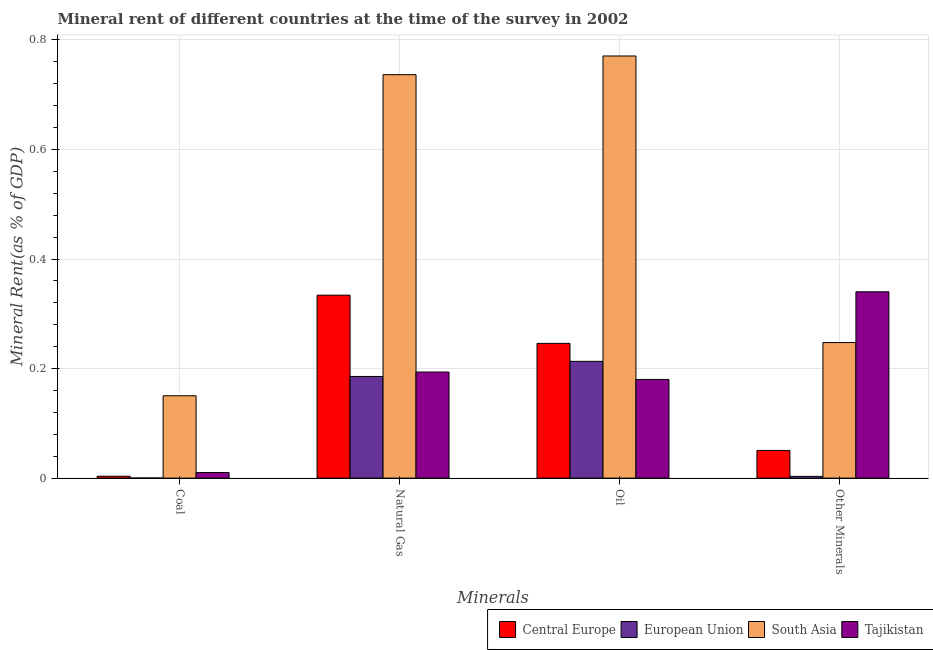How many different coloured bars are there?
Your answer should be compact. 4. How many bars are there on the 4th tick from the right?
Make the answer very short. 4. What is the label of the 4th group of bars from the left?
Keep it short and to the point. Other Minerals. What is the oil rent in South Asia?
Keep it short and to the point. 0.77. Across all countries, what is the maximum natural gas rent?
Your answer should be compact. 0.74. Across all countries, what is the minimum  rent of other minerals?
Offer a very short reply. 0. In which country was the  rent of other minerals maximum?
Give a very brief answer. Tajikistan. In which country was the coal rent minimum?
Your answer should be compact. European Union. What is the total  rent of other minerals in the graph?
Ensure brevity in your answer.  0.64. What is the difference between the  rent of other minerals in Central Europe and that in European Union?
Offer a terse response. 0.05. What is the difference between the natural gas rent in European Union and the oil rent in South Asia?
Keep it short and to the point. -0.59. What is the average natural gas rent per country?
Your response must be concise. 0.36. What is the difference between the oil rent and natural gas rent in Central Europe?
Make the answer very short. -0.09. What is the ratio of the  rent of other minerals in South Asia to that in Central Europe?
Provide a succinct answer. 4.9. What is the difference between the highest and the second highest coal rent?
Your response must be concise. 0.14. What is the difference between the highest and the lowest natural gas rent?
Offer a very short reply. 0.55. In how many countries, is the coal rent greater than the average coal rent taken over all countries?
Offer a terse response. 1. Is it the case that in every country, the sum of the oil rent and coal rent is greater than the sum of natural gas rent and  rent of other minerals?
Provide a short and direct response. No. What does the 4th bar from the left in Coal represents?
Offer a very short reply. Tajikistan. What does the 1st bar from the right in Natural Gas represents?
Keep it short and to the point. Tajikistan. How many bars are there?
Your answer should be very brief. 16. Are the values on the major ticks of Y-axis written in scientific E-notation?
Keep it short and to the point. No. Does the graph contain any zero values?
Offer a very short reply. No. How many legend labels are there?
Offer a terse response. 4. What is the title of the graph?
Your answer should be very brief. Mineral rent of different countries at the time of the survey in 2002. What is the label or title of the X-axis?
Make the answer very short. Minerals. What is the label or title of the Y-axis?
Provide a short and direct response. Mineral Rent(as % of GDP). What is the Mineral Rent(as % of GDP) of Central Europe in Coal?
Provide a short and direct response. 0. What is the Mineral Rent(as % of GDP) of European Union in Coal?
Give a very brief answer. 0. What is the Mineral Rent(as % of GDP) in South Asia in Coal?
Offer a very short reply. 0.15. What is the Mineral Rent(as % of GDP) of Tajikistan in Coal?
Make the answer very short. 0.01. What is the Mineral Rent(as % of GDP) of Central Europe in Natural Gas?
Offer a very short reply. 0.33. What is the Mineral Rent(as % of GDP) of European Union in Natural Gas?
Your answer should be compact. 0.19. What is the Mineral Rent(as % of GDP) of South Asia in Natural Gas?
Provide a succinct answer. 0.74. What is the Mineral Rent(as % of GDP) in Tajikistan in Natural Gas?
Provide a succinct answer. 0.19. What is the Mineral Rent(as % of GDP) in Central Europe in Oil?
Provide a short and direct response. 0.25. What is the Mineral Rent(as % of GDP) in European Union in Oil?
Your response must be concise. 0.21. What is the Mineral Rent(as % of GDP) of South Asia in Oil?
Your answer should be very brief. 0.77. What is the Mineral Rent(as % of GDP) of Tajikistan in Oil?
Your answer should be compact. 0.18. What is the Mineral Rent(as % of GDP) in Central Europe in Other Minerals?
Keep it short and to the point. 0.05. What is the Mineral Rent(as % of GDP) of European Union in Other Minerals?
Your answer should be very brief. 0. What is the Mineral Rent(as % of GDP) of South Asia in Other Minerals?
Ensure brevity in your answer.  0.25. What is the Mineral Rent(as % of GDP) in Tajikistan in Other Minerals?
Provide a short and direct response. 0.34. Across all Minerals, what is the maximum Mineral Rent(as % of GDP) of Central Europe?
Offer a very short reply. 0.33. Across all Minerals, what is the maximum Mineral Rent(as % of GDP) of European Union?
Make the answer very short. 0.21. Across all Minerals, what is the maximum Mineral Rent(as % of GDP) of South Asia?
Keep it short and to the point. 0.77. Across all Minerals, what is the maximum Mineral Rent(as % of GDP) in Tajikistan?
Your answer should be compact. 0.34. Across all Minerals, what is the minimum Mineral Rent(as % of GDP) in Central Europe?
Ensure brevity in your answer.  0. Across all Minerals, what is the minimum Mineral Rent(as % of GDP) in European Union?
Your answer should be very brief. 0. Across all Minerals, what is the minimum Mineral Rent(as % of GDP) of South Asia?
Keep it short and to the point. 0.15. Across all Minerals, what is the minimum Mineral Rent(as % of GDP) of Tajikistan?
Make the answer very short. 0.01. What is the total Mineral Rent(as % of GDP) of Central Europe in the graph?
Your answer should be very brief. 0.63. What is the total Mineral Rent(as % of GDP) in European Union in the graph?
Your answer should be very brief. 0.4. What is the total Mineral Rent(as % of GDP) of South Asia in the graph?
Offer a very short reply. 1.91. What is the total Mineral Rent(as % of GDP) in Tajikistan in the graph?
Provide a short and direct response. 0.72. What is the difference between the Mineral Rent(as % of GDP) in Central Europe in Coal and that in Natural Gas?
Keep it short and to the point. -0.33. What is the difference between the Mineral Rent(as % of GDP) of European Union in Coal and that in Natural Gas?
Keep it short and to the point. -0.19. What is the difference between the Mineral Rent(as % of GDP) in South Asia in Coal and that in Natural Gas?
Your answer should be very brief. -0.59. What is the difference between the Mineral Rent(as % of GDP) in Tajikistan in Coal and that in Natural Gas?
Provide a short and direct response. -0.18. What is the difference between the Mineral Rent(as % of GDP) of Central Europe in Coal and that in Oil?
Make the answer very short. -0.24. What is the difference between the Mineral Rent(as % of GDP) in European Union in Coal and that in Oil?
Your answer should be compact. -0.21. What is the difference between the Mineral Rent(as % of GDP) of South Asia in Coal and that in Oil?
Provide a short and direct response. -0.62. What is the difference between the Mineral Rent(as % of GDP) of Tajikistan in Coal and that in Oil?
Your response must be concise. -0.17. What is the difference between the Mineral Rent(as % of GDP) of Central Europe in Coal and that in Other Minerals?
Make the answer very short. -0.05. What is the difference between the Mineral Rent(as % of GDP) in European Union in Coal and that in Other Minerals?
Make the answer very short. -0. What is the difference between the Mineral Rent(as % of GDP) of South Asia in Coal and that in Other Minerals?
Your answer should be compact. -0.1. What is the difference between the Mineral Rent(as % of GDP) of Tajikistan in Coal and that in Other Minerals?
Your answer should be very brief. -0.33. What is the difference between the Mineral Rent(as % of GDP) of Central Europe in Natural Gas and that in Oil?
Provide a succinct answer. 0.09. What is the difference between the Mineral Rent(as % of GDP) in European Union in Natural Gas and that in Oil?
Your answer should be very brief. -0.03. What is the difference between the Mineral Rent(as % of GDP) of South Asia in Natural Gas and that in Oil?
Make the answer very short. -0.03. What is the difference between the Mineral Rent(as % of GDP) in Tajikistan in Natural Gas and that in Oil?
Keep it short and to the point. 0.01. What is the difference between the Mineral Rent(as % of GDP) of Central Europe in Natural Gas and that in Other Minerals?
Give a very brief answer. 0.28. What is the difference between the Mineral Rent(as % of GDP) of European Union in Natural Gas and that in Other Minerals?
Offer a very short reply. 0.18. What is the difference between the Mineral Rent(as % of GDP) of South Asia in Natural Gas and that in Other Minerals?
Keep it short and to the point. 0.49. What is the difference between the Mineral Rent(as % of GDP) in Tajikistan in Natural Gas and that in Other Minerals?
Offer a terse response. -0.15. What is the difference between the Mineral Rent(as % of GDP) in Central Europe in Oil and that in Other Minerals?
Your response must be concise. 0.2. What is the difference between the Mineral Rent(as % of GDP) of European Union in Oil and that in Other Minerals?
Make the answer very short. 0.21. What is the difference between the Mineral Rent(as % of GDP) in South Asia in Oil and that in Other Minerals?
Your answer should be very brief. 0.52. What is the difference between the Mineral Rent(as % of GDP) in Tajikistan in Oil and that in Other Minerals?
Provide a succinct answer. -0.16. What is the difference between the Mineral Rent(as % of GDP) in Central Europe in Coal and the Mineral Rent(as % of GDP) in European Union in Natural Gas?
Provide a succinct answer. -0.18. What is the difference between the Mineral Rent(as % of GDP) of Central Europe in Coal and the Mineral Rent(as % of GDP) of South Asia in Natural Gas?
Your answer should be very brief. -0.73. What is the difference between the Mineral Rent(as % of GDP) of Central Europe in Coal and the Mineral Rent(as % of GDP) of Tajikistan in Natural Gas?
Your response must be concise. -0.19. What is the difference between the Mineral Rent(as % of GDP) in European Union in Coal and the Mineral Rent(as % of GDP) in South Asia in Natural Gas?
Ensure brevity in your answer.  -0.74. What is the difference between the Mineral Rent(as % of GDP) in European Union in Coal and the Mineral Rent(as % of GDP) in Tajikistan in Natural Gas?
Offer a terse response. -0.19. What is the difference between the Mineral Rent(as % of GDP) in South Asia in Coal and the Mineral Rent(as % of GDP) in Tajikistan in Natural Gas?
Make the answer very short. -0.04. What is the difference between the Mineral Rent(as % of GDP) in Central Europe in Coal and the Mineral Rent(as % of GDP) in European Union in Oil?
Offer a very short reply. -0.21. What is the difference between the Mineral Rent(as % of GDP) in Central Europe in Coal and the Mineral Rent(as % of GDP) in South Asia in Oil?
Keep it short and to the point. -0.77. What is the difference between the Mineral Rent(as % of GDP) in Central Europe in Coal and the Mineral Rent(as % of GDP) in Tajikistan in Oil?
Your answer should be very brief. -0.18. What is the difference between the Mineral Rent(as % of GDP) of European Union in Coal and the Mineral Rent(as % of GDP) of South Asia in Oil?
Provide a short and direct response. -0.77. What is the difference between the Mineral Rent(as % of GDP) of European Union in Coal and the Mineral Rent(as % of GDP) of Tajikistan in Oil?
Offer a very short reply. -0.18. What is the difference between the Mineral Rent(as % of GDP) of South Asia in Coal and the Mineral Rent(as % of GDP) of Tajikistan in Oil?
Provide a short and direct response. -0.03. What is the difference between the Mineral Rent(as % of GDP) of Central Europe in Coal and the Mineral Rent(as % of GDP) of South Asia in Other Minerals?
Ensure brevity in your answer.  -0.24. What is the difference between the Mineral Rent(as % of GDP) in Central Europe in Coal and the Mineral Rent(as % of GDP) in Tajikistan in Other Minerals?
Give a very brief answer. -0.34. What is the difference between the Mineral Rent(as % of GDP) in European Union in Coal and the Mineral Rent(as % of GDP) in South Asia in Other Minerals?
Keep it short and to the point. -0.25. What is the difference between the Mineral Rent(as % of GDP) of European Union in Coal and the Mineral Rent(as % of GDP) of Tajikistan in Other Minerals?
Keep it short and to the point. -0.34. What is the difference between the Mineral Rent(as % of GDP) in South Asia in Coal and the Mineral Rent(as % of GDP) in Tajikistan in Other Minerals?
Make the answer very short. -0.19. What is the difference between the Mineral Rent(as % of GDP) in Central Europe in Natural Gas and the Mineral Rent(as % of GDP) in European Union in Oil?
Provide a short and direct response. 0.12. What is the difference between the Mineral Rent(as % of GDP) of Central Europe in Natural Gas and the Mineral Rent(as % of GDP) of South Asia in Oil?
Provide a succinct answer. -0.44. What is the difference between the Mineral Rent(as % of GDP) in Central Europe in Natural Gas and the Mineral Rent(as % of GDP) in Tajikistan in Oil?
Make the answer very short. 0.15. What is the difference between the Mineral Rent(as % of GDP) in European Union in Natural Gas and the Mineral Rent(as % of GDP) in South Asia in Oil?
Make the answer very short. -0.59. What is the difference between the Mineral Rent(as % of GDP) in European Union in Natural Gas and the Mineral Rent(as % of GDP) in Tajikistan in Oil?
Keep it short and to the point. 0.01. What is the difference between the Mineral Rent(as % of GDP) in South Asia in Natural Gas and the Mineral Rent(as % of GDP) in Tajikistan in Oil?
Your response must be concise. 0.56. What is the difference between the Mineral Rent(as % of GDP) in Central Europe in Natural Gas and the Mineral Rent(as % of GDP) in European Union in Other Minerals?
Make the answer very short. 0.33. What is the difference between the Mineral Rent(as % of GDP) in Central Europe in Natural Gas and the Mineral Rent(as % of GDP) in South Asia in Other Minerals?
Your answer should be very brief. 0.09. What is the difference between the Mineral Rent(as % of GDP) in Central Europe in Natural Gas and the Mineral Rent(as % of GDP) in Tajikistan in Other Minerals?
Offer a terse response. -0.01. What is the difference between the Mineral Rent(as % of GDP) of European Union in Natural Gas and the Mineral Rent(as % of GDP) of South Asia in Other Minerals?
Keep it short and to the point. -0.06. What is the difference between the Mineral Rent(as % of GDP) of European Union in Natural Gas and the Mineral Rent(as % of GDP) of Tajikistan in Other Minerals?
Provide a succinct answer. -0.15. What is the difference between the Mineral Rent(as % of GDP) in South Asia in Natural Gas and the Mineral Rent(as % of GDP) in Tajikistan in Other Minerals?
Your answer should be very brief. 0.4. What is the difference between the Mineral Rent(as % of GDP) of Central Europe in Oil and the Mineral Rent(as % of GDP) of European Union in Other Minerals?
Your answer should be very brief. 0.24. What is the difference between the Mineral Rent(as % of GDP) in Central Europe in Oil and the Mineral Rent(as % of GDP) in South Asia in Other Minerals?
Provide a short and direct response. -0. What is the difference between the Mineral Rent(as % of GDP) in Central Europe in Oil and the Mineral Rent(as % of GDP) in Tajikistan in Other Minerals?
Provide a short and direct response. -0.09. What is the difference between the Mineral Rent(as % of GDP) of European Union in Oil and the Mineral Rent(as % of GDP) of South Asia in Other Minerals?
Your response must be concise. -0.03. What is the difference between the Mineral Rent(as % of GDP) of European Union in Oil and the Mineral Rent(as % of GDP) of Tajikistan in Other Minerals?
Keep it short and to the point. -0.13. What is the difference between the Mineral Rent(as % of GDP) of South Asia in Oil and the Mineral Rent(as % of GDP) of Tajikistan in Other Minerals?
Your answer should be very brief. 0.43. What is the average Mineral Rent(as % of GDP) in Central Europe per Minerals?
Give a very brief answer. 0.16. What is the average Mineral Rent(as % of GDP) of European Union per Minerals?
Provide a short and direct response. 0.1. What is the average Mineral Rent(as % of GDP) of South Asia per Minerals?
Your answer should be very brief. 0.48. What is the average Mineral Rent(as % of GDP) of Tajikistan per Minerals?
Your answer should be very brief. 0.18. What is the difference between the Mineral Rent(as % of GDP) in Central Europe and Mineral Rent(as % of GDP) in European Union in Coal?
Keep it short and to the point. 0. What is the difference between the Mineral Rent(as % of GDP) in Central Europe and Mineral Rent(as % of GDP) in South Asia in Coal?
Your response must be concise. -0.15. What is the difference between the Mineral Rent(as % of GDP) of Central Europe and Mineral Rent(as % of GDP) of Tajikistan in Coal?
Make the answer very short. -0.01. What is the difference between the Mineral Rent(as % of GDP) of European Union and Mineral Rent(as % of GDP) of South Asia in Coal?
Provide a short and direct response. -0.15. What is the difference between the Mineral Rent(as % of GDP) in European Union and Mineral Rent(as % of GDP) in Tajikistan in Coal?
Your response must be concise. -0.01. What is the difference between the Mineral Rent(as % of GDP) of South Asia and Mineral Rent(as % of GDP) of Tajikistan in Coal?
Offer a terse response. 0.14. What is the difference between the Mineral Rent(as % of GDP) in Central Europe and Mineral Rent(as % of GDP) in European Union in Natural Gas?
Ensure brevity in your answer.  0.15. What is the difference between the Mineral Rent(as % of GDP) in Central Europe and Mineral Rent(as % of GDP) in South Asia in Natural Gas?
Ensure brevity in your answer.  -0.4. What is the difference between the Mineral Rent(as % of GDP) of Central Europe and Mineral Rent(as % of GDP) of Tajikistan in Natural Gas?
Your answer should be compact. 0.14. What is the difference between the Mineral Rent(as % of GDP) of European Union and Mineral Rent(as % of GDP) of South Asia in Natural Gas?
Give a very brief answer. -0.55. What is the difference between the Mineral Rent(as % of GDP) in European Union and Mineral Rent(as % of GDP) in Tajikistan in Natural Gas?
Provide a succinct answer. -0.01. What is the difference between the Mineral Rent(as % of GDP) in South Asia and Mineral Rent(as % of GDP) in Tajikistan in Natural Gas?
Your answer should be very brief. 0.54. What is the difference between the Mineral Rent(as % of GDP) in Central Europe and Mineral Rent(as % of GDP) in European Union in Oil?
Offer a very short reply. 0.03. What is the difference between the Mineral Rent(as % of GDP) in Central Europe and Mineral Rent(as % of GDP) in South Asia in Oil?
Your answer should be very brief. -0.52. What is the difference between the Mineral Rent(as % of GDP) in Central Europe and Mineral Rent(as % of GDP) in Tajikistan in Oil?
Ensure brevity in your answer.  0.07. What is the difference between the Mineral Rent(as % of GDP) in European Union and Mineral Rent(as % of GDP) in South Asia in Oil?
Your answer should be very brief. -0.56. What is the difference between the Mineral Rent(as % of GDP) in European Union and Mineral Rent(as % of GDP) in Tajikistan in Oil?
Your answer should be very brief. 0.03. What is the difference between the Mineral Rent(as % of GDP) in South Asia and Mineral Rent(as % of GDP) in Tajikistan in Oil?
Your answer should be very brief. 0.59. What is the difference between the Mineral Rent(as % of GDP) of Central Europe and Mineral Rent(as % of GDP) of European Union in Other Minerals?
Provide a succinct answer. 0.05. What is the difference between the Mineral Rent(as % of GDP) in Central Europe and Mineral Rent(as % of GDP) in South Asia in Other Minerals?
Provide a succinct answer. -0.2. What is the difference between the Mineral Rent(as % of GDP) of Central Europe and Mineral Rent(as % of GDP) of Tajikistan in Other Minerals?
Keep it short and to the point. -0.29. What is the difference between the Mineral Rent(as % of GDP) of European Union and Mineral Rent(as % of GDP) of South Asia in Other Minerals?
Your answer should be compact. -0.24. What is the difference between the Mineral Rent(as % of GDP) of European Union and Mineral Rent(as % of GDP) of Tajikistan in Other Minerals?
Provide a short and direct response. -0.34. What is the difference between the Mineral Rent(as % of GDP) of South Asia and Mineral Rent(as % of GDP) of Tajikistan in Other Minerals?
Your answer should be very brief. -0.09. What is the ratio of the Mineral Rent(as % of GDP) in Central Europe in Coal to that in Natural Gas?
Give a very brief answer. 0.01. What is the ratio of the Mineral Rent(as % of GDP) of European Union in Coal to that in Natural Gas?
Offer a terse response. 0. What is the ratio of the Mineral Rent(as % of GDP) of South Asia in Coal to that in Natural Gas?
Offer a very short reply. 0.2. What is the ratio of the Mineral Rent(as % of GDP) of Tajikistan in Coal to that in Natural Gas?
Offer a very short reply. 0.05. What is the ratio of the Mineral Rent(as % of GDP) of Central Europe in Coal to that in Oil?
Offer a very short reply. 0.01. What is the ratio of the Mineral Rent(as % of GDP) of European Union in Coal to that in Oil?
Provide a short and direct response. 0. What is the ratio of the Mineral Rent(as % of GDP) of South Asia in Coal to that in Oil?
Keep it short and to the point. 0.2. What is the ratio of the Mineral Rent(as % of GDP) in Tajikistan in Coal to that in Oil?
Keep it short and to the point. 0.06. What is the ratio of the Mineral Rent(as % of GDP) in Central Europe in Coal to that in Other Minerals?
Your answer should be very brief. 0.07. What is the ratio of the Mineral Rent(as % of GDP) in European Union in Coal to that in Other Minerals?
Your response must be concise. 0.06. What is the ratio of the Mineral Rent(as % of GDP) of South Asia in Coal to that in Other Minerals?
Provide a succinct answer. 0.61. What is the ratio of the Mineral Rent(as % of GDP) of Central Europe in Natural Gas to that in Oil?
Your response must be concise. 1.36. What is the ratio of the Mineral Rent(as % of GDP) of European Union in Natural Gas to that in Oil?
Give a very brief answer. 0.87. What is the ratio of the Mineral Rent(as % of GDP) of South Asia in Natural Gas to that in Oil?
Keep it short and to the point. 0.96. What is the ratio of the Mineral Rent(as % of GDP) of Tajikistan in Natural Gas to that in Oil?
Offer a terse response. 1.08. What is the ratio of the Mineral Rent(as % of GDP) of Central Europe in Natural Gas to that in Other Minerals?
Your answer should be compact. 6.61. What is the ratio of the Mineral Rent(as % of GDP) of European Union in Natural Gas to that in Other Minerals?
Your answer should be compact. 57.55. What is the ratio of the Mineral Rent(as % of GDP) in South Asia in Natural Gas to that in Other Minerals?
Ensure brevity in your answer.  2.98. What is the ratio of the Mineral Rent(as % of GDP) of Tajikistan in Natural Gas to that in Other Minerals?
Provide a succinct answer. 0.57. What is the ratio of the Mineral Rent(as % of GDP) in Central Europe in Oil to that in Other Minerals?
Keep it short and to the point. 4.87. What is the ratio of the Mineral Rent(as % of GDP) in European Union in Oil to that in Other Minerals?
Offer a very short reply. 66.11. What is the ratio of the Mineral Rent(as % of GDP) of South Asia in Oil to that in Other Minerals?
Your answer should be compact. 3.11. What is the ratio of the Mineral Rent(as % of GDP) of Tajikistan in Oil to that in Other Minerals?
Ensure brevity in your answer.  0.53. What is the difference between the highest and the second highest Mineral Rent(as % of GDP) in Central Europe?
Give a very brief answer. 0.09. What is the difference between the highest and the second highest Mineral Rent(as % of GDP) in European Union?
Ensure brevity in your answer.  0.03. What is the difference between the highest and the second highest Mineral Rent(as % of GDP) in South Asia?
Offer a very short reply. 0.03. What is the difference between the highest and the second highest Mineral Rent(as % of GDP) in Tajikistan?
Give a very brief answer. 0.15. What is the difference between the highest and the lowest Mineral Rent(as % of GDP) in Central Europe?
Your answer should be very brief. 0.33. What is the difference between the highest and the lowest Mineral Rent(as % of GDP) in European Union?
Your response must be concise. 0.21. What is the difference between the highest and the lowest Mineral Rent(as % of GDP) of South Asia?
Keep it short and to the point. 0.62. What is the difference between the highest and the lowest Mineral Rent(as % of GDP) of Tajikistan?
Provide a short and direct response. 0.33. 